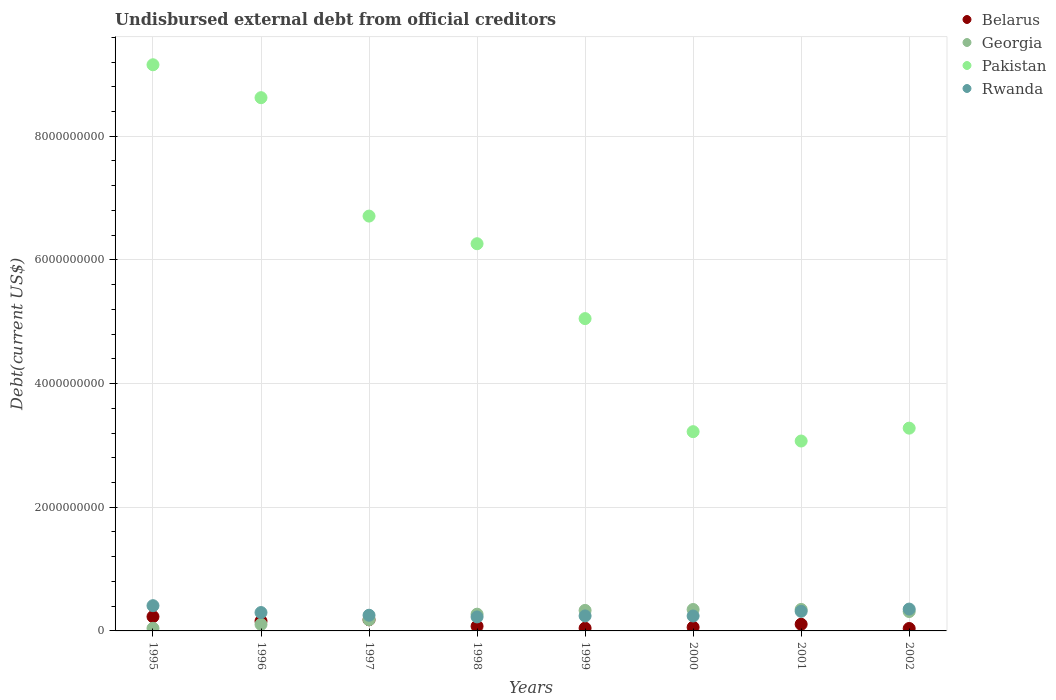What is the total debt in Pakistan in 1999?
Make the answer very short. 5.05e+09. Across all years, what is the maximum total debt in Rwanda?
Offer a terse response. 4.08e+08. Across all years, what is the minimum total debt in Belarus?
Give a very brief answer. 3.94e+07. In which year was the total debt in Rwanda minimum?
Your answer should be compact. 1998. What is the total total debt in Belarus in the graph?
Give a very brief answer. 8.97e+08. What is the difference between the total debt in Rwanda in 1998 and that in 1999?
Your answer should be very brief. -1.64e+07. What is the difference between the total debt in Belarus in 1995 and the total debt in Georgia in 1996?
Your answer should be compact. 1.26e+08. What is the average total debt in Rwanda per year?
Your response must be concise. 2.92e+08. In the year 2002, what is the difference between the total debt in Pakistan and total debt in Belarus?
Ensure brevity in your answer.  3.24e+09. What is the ratio of the total debt in Belarus in 1995 to that in 1996?
Offer a terse response. 1.45. Is the total debt in Pakistan in 1996 less than that in 2002?
Keep it short and to the point. No. Is the difference between the total debt in Pakistan in 2000 and 2002 greater than the difference between the total debt in Belarus in 2000 and 2002?
Provide a short and direct response. No. What is the difference between the highest and the second highest total debt in Pakistan?
Your answer should be very brief. 5.32e+08. What is the difference between the highest and the lowest total debt in Rwanda?
Your answer should be very brief. 1.82e+08. In how many years, is the total debt in Georgia greater than the average total debt in Georgia taken over all years?
Provide a short and direct response. 5. Is the sum of the total debt in Belarus in 1999 and 2000 greater than the maximum total debt in Rwanda across all years?
Ensure brevity in your answer.  No. Does the total debt in Rwanda monotonically increase over the years?
Ensure brevity in your answer.  No. Is the total debt in Georgia strictly less than the total debt in Belarus over the years?
Your response must be concise. No. How many dotlines are there?
Provide a short and direct response. 4. How many years are there in the graph?
Your answer should be very brief. 8. What is the difference between two consecutive major ticks on the Y-axis?
Offer a very short reply. 2.00e+09. Does the graph contain any zero values?
Give a very brief answer. No. How many legend labels are there?
Provide a short and direct response. 4. How are the legend labels stacked?
Offer a very short reply. Vertical. What is the title of the graph?
Provide a short and direct response. Undisbursed external debt from official creditors. Does "Bosnia and Herzegovina" appear as one of the legend labels in the graph?
Make the answer very short. No. What is the label or title of the Y-axis?
Give a very brief answer. Debt(current US$). What is the Debt(current US$) in Belarus in 1995?
Offer a very short reply. 2.31e+08. What is the Debt(current US$) of Georgia in 1995?
Your response must be concise. 4.22e+07. What is the Debt(current US$) in Pakistan in 1995?
Provide a succinct answer. 9.16e+09. What is the Debt(current US$) of Rwanda in 1995?
Keep it short and to the point. 4.08e+08. What is the Debt(current US$) of Belarus in 1996?
Ensure brevity in your answer.  1.59e+08. What is the Debt(current US$) of Georgia in 1996?
Offer a terse response. 1.05e+08. What is the Debt(current US$) in Pakistan in 1996?
Give a very brief answer. 8.62e+09. What is the Debt(current US$) in Rwanda in 1996?
Offer a terse response. 2.97e+08. What is the Debt(current US$) in Belarus in 1997?
Offer a terse response. 1.80e+08. What is the Debt(current US$) of Georgia in 1997?
Your answer should be very brief. 1.81e+08. What is the Debt(current US$) of Pakistan in 1997?
Your answer should be very brief. 6.71e+09. What is the Debt(current US$) of Rwanda in 1997?
Make the answer very short. 2.54e+08. What is the Debt(current US$) in Belarus in 1998?
Make the answer very short. 7.55e+07. What is the Debt(current US$) of Georgia in 1998?
Provide a succinct answer. 2.71e+08. What is the Debt(current US$) of Pakistan in 1998?
Provide a succinct answer. 6.26e+09. What is the Debt(current US$) in Rwanda in 1998?
Offer a terse response. 2.26e+08. What is the Debt(current US$) of Belarus in 1999?
Keep it short and to the point. 4.48e+07. What is the Debt(current US$) of Georgia in 1999?
Give a very brief answer. 3.32e+08. What is the Debt(current US$) in Pakistan in 1999?
Your response must be concise. 5.05e+09. What is the Debt(current US$) of Rwanda in 1999?
Your answer should be compact. 2.43e+08. What is the Debt(current US$) in Belarus in 2000?
Provide a short and direct response. 5.90e+07. What is the Debt(current US$) in Georgia in 2000?
Provide a short and direct response. 3.46e+08. What is the Debt(current US$) of Pakistan in 2000?
Give a very brief answer. 3.22e+09. What is the Debt(current US$) in Rwanda in 2000?
Ensure brevity in your answer.  2.42e+08. What is the Debt(current US$) in Belarus in 2001?
Offer a very short reply. 1.08e+08. What is the Debt(current US$) of Georgia in 2001?
Provide a succinct answer. 3.47e+08. What is the Debt(current US$) of Pakistan in 2001?
Offer a terse response. 3.07e+09. What is the Debt(current US$) of Rwanda in 2001?
Your answer should be compact. 3.17e+08. What is the Debt(current US$) in Belarus in 2002?
Your answer should be very brief. 3.94e+07. What is the Debt(current US$) of Georgia in 2002?
Provide a short and direct response. 3.14e+08. What is the Debt(current US$) in Pakistan in 2002?
Your answer should be very brief. 3.28e+09. What is the Debt(current US$) in Rwanda in 2002?
Offer a very short reply. 3.53e+08. Across all years, what is the maximum Debt(current US$) of Belarus?
Your answer should be compact. 2.31e+08. Across all years, what is the maximum Debt(current US$) in Georgia?
Keep it short and to the point. 3.47e+08. Across all years, what is the maximum Debt(current US$) of Pakistan?
Keep it short and to the point. 9.16e+09. Across all years, what is the maximum Debt(current US$) of Rwanda?
Keep it short and to the point. 4.08e+08. Across all years, what is the minimum Debt(current US$) of Belarus?
Keep it short and to the point. 3.94e+07. Across all years, what is the minimum Debt(current US$) of Georgia?
Ensure brevity in your answer.  4.22e+07. Across all years, what is the minimum Debt(current US$) of Pakistan?
Your response must be concise. 3.07e+09. Across all years, what is the minimum Debt(current US$) in Rwanda?
Your response must be concise. 2.26e+08. What is the total Debt(current US$) in Belarus in the graph?
Provide a short and direct response. 8.97e+08. What is the total Debt(current US$) of Georgia in the graph?
Provide a short and direct response. 1.94e+09. What is the total Debt(current US$) of Pakistan in the graph?
Offer a very short reply. 4.54e+1. What is the total Debt(current US$) of Rwanda in the graph?
Provide a short and direct response. 2.34e+09. What is the difference between the Debt(current US$) of Belarus in 1995 and that in 1996?
Make the answer very short. 7.12e+07. What is the difference between the Debt(current US$) in Georgia in 1995 and that in 1996?
Your answer should be compact. -6.29e+07. What is the difference between the Debt(current US$) in Pakistan in 1995 and that in 1996?
Ensure brevity in your answer.  5.32e+08. What is the difference between the Debt(current US$) in Rwanda in 1995 and that in 1996?
Provide a short and direct response. 1.11e+08. What is the difference between the Debt(current US$) in Belarus in 1995 and that in 1997?
Offer a terse response. 5.06e+07. What is the difference between the Debt(current US$) of Georgia in 1995 and that in 1997?
Your answer should be compact. -1.39e+08. What is the difference between the Debt(current US$) of Pakistan in 1995 and that in 1997?
Provide a short and direct response. 2.45e+09. What is the difference between the Debt(current US$) in Rwanda in 1995 and that in 1997?
Ensure brevity in your answer.  1.55e+08. What is the difference between the Debt(current US$) of Belarus in 1995 and that in 1998?
Your answer should be very brief. 1.55e+08. What is the difference between the Debt(current US$) of Georgia in 1995 and that in 1998?
Keep it short and to the point. -2.29e+08. What is the difference between the Debt(current US$) in Pakistan in 1995 and that in 1998?
Offer a very short reply. 2.89e+09. What is the difference between the Debt(current US$) in Rwanda in 1995 and that in 1998?
Keep it short and to the point. 1.82e+08. What is the difference between the Debt(current US$) of Belarus in 1995 and that in 1999?
Your response must be concise. 1.86e+08. What is the difference between the Debt(current US$) in Georgia in 1995 and that in 1999?
Ensure brevity in your answer.  -2.90e+08. What is the difference between the Debt(current US$) of Pakistan in 1995 and that in 1999?
Keep it short and to the point. 4.11e+09. What is the difference between the Debt(current US$) in Rwanda in 1995 and that in 1999?
Make the answer very short. 1.65e+08. What is the difference between the Debt(current US$) in Belarus in 1995 and that in 2000?
Your answer should be compact. 1.72e+08. What is the difference between the Debt(current US$) in Georgia in 1995 and that in 2000?
Your answer should be very brief. -3.04e+08. What is the difference between the Debt(current US$) in Pakistan in 1995 and that in 2000?
Ensure brevity in your answer.  5.93e+09. What is the difference between the Debt(current US$) of Rwanda in 1995 and that in 2000?
Offer a very short reply. 1.67e+08. What is the difference between the Debt(current US$) in Belarus in 1995 and that in 2001?
Your answer should be very brief. 1.23e+08. What is the difference between the Debt(current US$) of Georgia in 1995 and that in 2001?
Give a very brief answer. -3.05e+08. What is the difference between the Debt(current US$) of Pakistan in 1995 and that in 2001?
Provide a succinct answer. 6.08e+09. What is the difference between the Debt(current US$) in Rwanda in 1995 and that in 2001?
Give a very brief answer. 9.11e+07. What is the difference between the Debt(current US$) in Belarus in 1995 and that in 2002?
Give a very brief answer. 1.91e+08. What is the difference between the Debt(current US$) in Georgia in 1995 and that in 2002?
Provide a short and direct response. -2.71e+08. What is the difference between the Debt(current US$) of Pakistan in 1995 and that in 2002?
Provide a short and direct response. 5.88e+09. What is the difference between the Debt(current US$) of Rwanda in 1995 and that in 2002?
Keep it short and to the point. 5.49e+07. What is the difference between the Debt(current US$) in Belarus in 1996 and that in 1997?
Your answer should be compact. -2.06e+07. What is the difference between the Debt(current US$) of Georgia in 1996 and that in 1997?
Your answer should be very brief. -7.58e+07. What is the difference between the Debt(current US$) of Pakistan in 1996 and that in 1997?
Your answer should be compact. 1.91e+09. What is the difference between the Debt(current US$) of Rwanda in 1996 and that in 1997?
Your answer should be very brief. 4.35e+07. What is the difference between the Debt(current US$) of Belarus in 1996 and that in 1998?
Your response must be concise. 8.40e+07. What is the difference between the Debt(current US$) of Georgia in 1996 and that in 1998?
Make the answer very short. -1.66e+08. What is the difference between the Debt(current US$) of Pakistan in 1996 and that in 1998?
Provide a succinct answer. 2.36e+09. What is the difference between the Debt(current US$) of Rwanda in 1996 and that in 1998?
Provide a succinct answer. 7.08e+07. What is the difference between the Debt(current US$) in Belarus in 1996 and that in 1999?
Offer a very short reply. 1.15e+08. What is the difference between the Debt(current US$) of Georgia in 1996 and that in 1999?
Your answer should be very brief. -2.27e+08. What is the difference between the Debt(current US$) in Pakistan in 1996 and that in 1999?
Give a very brief answer. 3.57e+09. What is the difference between the Debt(current US$) of Rwanda in 1996 and that in 1999?
Provide a short and direct response. 5.44e+07. What is the difference between the Debt(current US$) of Belarus in 1996 and that in 2000?
Your answer should be very brief. 1.00e+08. What is the difference between the Debt(current US$) in Georgia in 1996 and that in 2000?
Provide a short and direct response. -2.41e+08. What is the difference between the Debt(current US$) in Pakistan in 1996 and that in 2000?
Keep it short and to the point. 5.40e+09. What is the difference between the Debt(current US$) in Rwanda in 1996 and that in 2000?
Your answer should be very brief. 5.55e+07. What is the difference between the Debt(current US$) of Belarus in 1996 and that in 2001?
Keep it short and to the point. 5.16e+07. What is the difference between the Debt(current US$) of Georgia in 1996 and that in 2001?
Provide a short and direct response. -2.42e+08. What is the difference between the Debt(current US$) of Pakistan in 1996 and that in 2001?
Make the answer very short. 5.55e+09. What is the difference between the Debt(current US$) of Rwanda in 1996 and that in 2001?
Offer a terse response. -1.99e+07. What is the difference between the Debt(current US$) in Belarus in 1996 and that in 2002?
Provide a short and direct response. 1.20e+08. What is the difference between the Debt(current US$) in Georgia in 1996 and that in 2002?
Ensure brevity in your answer.  -2.09e+08. What is the difference between the Debt(current US$) in Pakistan in 1996 and that in 2002?
Offer a terse response. 5.34e+09. What is the difference between the Debt(current US$) in Rwanda in 1996 and that in 2002?
Ensure brevity in your answer.  -5.61e+07. What is the difference between the Debt(current US$) in Belarus in 1997 and that in 1998?
Your response must be concise. 1.05e+08. What is the difference between the Debt(current US$) in Georgia in 1997 and that in 1998?
Offer a terse response. -8.99e+07. What is the difference between the Debt(current US$) of Pakistan in 1997 and that in 1998?
Ensure brevity in your answer.  4.47e+08. What is the difference between the Debt(current US$) of Rwanda in 1997 and that in 1998?
Your response must be concise. 2.73e+07. What is the difference between the Debt(current US$) of Belarus in 1997 and that in 1999?
Your answer should be compact. 1.35e+08. What is the difference between the Debt(current US$) of Georgia in 1997 and that in 1999?
Make the answer very short. -1.51e+08. What is the difference between the Debt(current US$) of Pakistan in 1997 and that in 1999?
Your answer should be compact. 1.66e+09. What is the difference between the Debt(current US$) in Rwanda in 1997 and that in 1999?
Provide a short and direct response. 1.09e+07. What is the difference between the Debt(current US$) in Belarus in 1997 and that in 2000?
Offer a terse response. 1.21e+08. What is the difference between the Debt(current US$) of Georgia in 1997 and that in 2000?
Ensure brevity in your answer.  -1.65e+08. What is the difference between the Debt(current US$) in Pakistan in 1997 and that in 2000?
Your answer should be very brief. 3.49e+09. What is the difference between the Debt(current US$) of Rwanda in 1997 and that in 2000?
Offer a very short reply. 1.20e+07. What is the difference between the Debt(current US$) of Belarus in 1997 and that in 2001?
Give a very brief answer. 7.22e+07. What is the difference between the Debt(current US$) in Georgia in 1997 and that in 2001?
Offer a very short reply. -1.66e+08. What is the difference between the Debt(current US$) of Pakistan in 1997 and that in 2001?
Offer a very short reply. 3.64e+09. What is the difference between the Debt(current US$) of Rwanda in 1997 and that in 2001?
Offer a very short reply. -6.35e+07. What is the difference between the Debt(current US$) of Belarus in 1997 and that in 2002?
Keep it short and to the point. 1.41e+08. What is the difference between the Debt(current US$) of Georgia in 1997 and that in 2002?
Offer a terse response. -1.33e+08. What is the difference between the Debt(current US$) in Pakistan in 1997 and that in 2002?
Your response must be concise. 3.43e+09. What is the difference between the Debt(current US$) in Rwanda in 1997 and that in 2002?
Your answer should be compact. -9.96e+07. What is the difference between the Debt(current US$) of Belarus in 1998 and that in 1999?
Offer a very short reply. 3.07e+07. What is the difference between the Debt(current US$) of Georgia in 1998 and that in 1999?
Keep it short and to the point. -6.10e+07. What is the difference between the Debt(current US$) of Pakistan in 1998 and that in 1999?
Your response must be concise. 1.21e+09. What is the difference between the Debt(current US$) in Rwanda in 1998 and that in 1999?
Your answer should be very brief. -1.64e+07. What is the difference between the Debt(current US$) in Belarus in 1998 and that in 2000?
Offer a terse response. 1.64e+07. What is the difference between the Debt(current US$) of Georgia in 1998 and that in 2000?
Your answer should be very brief. -7.55e+07. What is the difference between the Debt(current US$) in Pakistan in 1998 and that in 2000?
Offer a very short reply. 3.04e+09. What is the difference between the Debt(current US$) of Rwanda in 1998 and that in 2000?
Your answer should be very brief. -1.52e+07. What is the difference between the Debt(current US$) in Belarus in 1998 and that in 2001?
Keep it short and to the point. -3.24e+07. What is the difference between the Debt(current US$) of Georgia in 1998 and that in 2001?
Your answer should be very brief. -7.65e+07. What is the difference between the Debt(current US$) in Pakistan in 1998 and that in 2001?
Your answer should be very brief. 3.19e+09. What is the difference between the Debt(current US$) of Rwanda in 1998 and that in 2001?
Your response must be concise. -9.07e+07. What is the difference between the Debt(current US$) in Belarus in 1998 and that in 2002?
Offer a very short reply. 3.61e+07. What is the difference between the Debt(current US$) of Georgia in 1998 and that in 2002?
Offer a terse response. -4.28e+07. What is the difference between the Debt(current US$) in Pakistan in 1998 and that in 2002?
Keep it short and to the point. 2.98e+09. What is the difference between the Debt(current US$) in Rwanda in 1998 and that in 2002?
Provide a succinct answer. -1.27e+08. What is the difference between the Debt(current US$) of Belarus in 1999 and that in 2000?
Your response must be concise. -1.43e+07. What is the difference between the Debt(current US$) in Georgia in 1999 and that in 2000?
Provide a succinct answer. -1.45e+07. What is the difference between the Debt(current US$) of Pakistan in 1999 and that in 2000?
Offer a very short reply. 1.83e+09. What is the difference between the Debt(current US$) in Rwanda in 1999 and that in 2000?
Provide a short and direct response. 1.11e+06. What is the difference between the Debt(current US$) of Belarus in 1999 and that in 2001?
Your answer should be compact. -6.31e+07. What is the difference between the Debt(current US$) of Georgia in 1999 and that in 2001?
Offer a terse response. -1.55e+07. What is the difference between the Debt(current US$) in Pakistan in 1999 and that in 2001?
Ensure brevity in your answer.  1.98e+09. What is the difference between the Debt(current US$) of Rwanda in 1999 and that in 2001?
Your answer should be compact. -7.43e+07. What is the difference between the Debt(current US$) of Belarus in 1999 and that in 2002?
Your answer should be very brief. 5.39e+06. What is the difference between the Debt(current US$) in Georgia in 1999 and that in 2002?
Give a very brief answer. 1.82e+07. What is the difference between the Debt(current US$) in Pakistan in 1999 and that in 2002?
Make the answer very short. 1.77e+09. What is the difference between the Debt(current US$) of Rwanda in 1999 and that in 2002?
Your answer should be compact. -1.11e+08. What is the difference between the Debt(current US$) in Belarus in 2000 and that in 2001?
Your answer should be very brief. -4.88e+07. What is the difference between the Debt(current US$) of Georgia in 2000 and that in 2001?
Ensure brevity in your answer.  -1.02e+06. What is the difference between the Debt(current US$) in Pakistan in 2000 and that in 2001?
Provide a succinct answer. 1.51e+08. What is the difference between the Debt(current US$) in Rwanda in 2000 and that in 2001?
Your response must be concise. -7.55e+07. What is the difference between the Debt(current US$) of Belarus in 2000 and that in 2002?
Provide a short and direct response. 1.96e+07. What is the difference between the Debt(current US$) in Georgia in 2000 and that in 2002?
Provide a succinct answer. 3.27e+07. What is the difference between the Debt(current US$) of Pakistan in 2000 and that in 2002?
Ensure brevity in your answer.  -5.69e+07. What is the difference between the Debt(current US$) of Rwanda in 2000 and that in 2002?
Offer a very short reply. -1.12e+08. What is the difference between the Debt(current US$) of Belarus in 2001 and that in 2002?
Provide a short and direct response. 6.85e+07. What is the difference between the Debt(current US$) of Georgia in 2001 and that in 2002?
Your answer should be compact. 3.37e+07. What is the difference between the Debt(current US$) of Pakistan in 2001 and that in 2002?
Provide a succinct answer. -2.08e+08. What is the difference between the Debt(current US$) in Rwanda in 2001 and that in 2002?
Provide a short and direct response. -3.62e+07. What is the difference between the Debt(current US$) in Belarus in 1995 and the Debt(current US$) in Georgia in 1996?
Your answer should be very brief. 1.26e+08. What is the difference between the Debt(current US$) in Belarus in 1995 and the Debt(current US$) in Pakistan in 1996?
Offer a terse response. -8.39e+09. What is the difference between the Debt(current US$) of Belarus in 1995 and the Debt(current US$) of Rwanda in 1996?
Give a very brief answer. -6.65e+07. What is the difference between the Debt(current US$) of Georgia in 1995 and the Debt(current US$) of Pakistan in 1996?
Offer a very short reply. -8.58e+09. What is the difference between the Debt(current US$) of Georgia in 1995 and the Debt(current US$) of Rwanda in 1996?
Your answer should be compact. -2.55e+08. What is the difference between the Debt(current US$) in Pakistan in 1995 and the Debt(current US$) in Rwanda in 1996?
Your answer should be compact. 8.86e+09. What is the difference between the Debt(current US$) in Belarus in 1995 and the Debt(current US$) in Georgia in 1997?
Offer a terse response. 4.98e+07. What is the difference between the Debt(current US$) in Belarus in 1995 and the Debt(current US$) in Pakistan in 1997?
Your answer should be very brief. -6.48e+09. What is the difference between the Debt(current US$) in Belarus in 1995 and the Debt(current US$) in Rwanda in 1997?
Ensure brevity in your answer.  -2.30e+07. What is the difference between the Debt(current US$) in Georgia in 1995 and the Debt(current US$) in Pakistan in 1997?
Your answer should be very brief. -6.67e+09. What is the difference between the Debt(current US$) of Georgia in 1995 and the Debt(current US$) of Rwanda in 1997?
Provide a short and direct response. -2.11e+08. What is the difference between the Debt(current US$) of Pakistan in 1995 and the Debt(current US$) of Rwanda in 1997?
Ensure brevity in your answer.  8.90e+09. What is the difference between the Debt(current US$) of Belarus in 1995 and the Debt(current US$) of Georgia in 1998?
Provide a succinct answer. -4.01e+07. What is the difference between the Debt(current US$) of Belarus in 1995 and the Debt(current US$) of Pakistan in 1998?
Give a very brief answer. -6.03e+09. What is the difference between the Debt(current US$) of Belarus in 1995 and the Debt(current US$) of Rwanda in 1998?
Offer a terse response. 4.30e+06. What is the difference between the Debt(current US$) of Georgia in 1995 and the Debt(current US$) of Pakistan in 1998?
Provide a short and direct response. -6.22e+09. What is the difference between the Debt(current US$) of Georgia in 1995 and the Debt(current US$) of Rwanda in 1998?
Provide a short and direct response. -1.84e+08. What is the difference between the Debt(current US$) of Pakistan in 1995 and the Debt(current US$) of Rwanda in 1998?
Your response must be concise. 8.93e+09. What is the difference between the Debt(current US$) of Belarus in 1995 and the Debt(current US$) of Georgia in 1999?
Offer a very short reply. -1.01e+08. What is the difference between the Debt(current US$) of Belarus in 1995 and the Debt(current US$) of Pakistan in 1999?
Your response must be concise. -4.82e+09. What is the difference between the Debt(current US$) in Belarus in 1995 and the Debt(current US$) in Rwanda in 1999?
Provide a short and direct response. -1.21e+07. What is the difference between the Debt(current US$) in Georgia in 1995 and the Debt(current US$) in Pakistan in 1999?
Provide a short and direct response. -5.01e+09. What is the difference between the Debt(current US$) of Georgia in 1995 and the Debt(current US$) of Rwanda in 1999?
Ensure brevity in your answer.  -2.01e+08. What is the difference between the Debt(current US$) in Pakistan in 1995 and the Debt(current US$) in Rwanda in 1999?
Offer a terse response. 8.91e+09. What is the difference between the Debt(current US$) in Belarus in 1995 and the Debt(current US$) in Georgia in 2000?
Your answer should be very brief. -1.16e+08. What is the difference between the Debt(current US$) of Belarus in 1995 and the Debt(current US$) of Pakistan in 2000?
Give a very brief answer. -2.99e+09. What is the difference between the Debt(current US$) in Belarus in 1995 and the Debt(current US$) in Rwanda in 2000?
Offer a very short reply. -1.10e+07. What is the difference between the Debt(current US$) of Georgia in 1995 and the Debt(current US$) of Pakistan in 2000?
Give a very brief answer. -3.18e+09. What is the difference between the Debt(current US$) of Georgia in 1995 and the Debt(current US$) of Rwanda in 2000?
Your response must be concise. -1.99e+08. What is the difference between the Debt(current US$) in Pakistan in 1995 and the Debt(current US$) in Rwanda in 2000?
Keep it short and to the point. 8.91e+09. What is the difference between the Debt(current US$) of Belarus in 1995 and the Debt(current US$) of Georgia in 2001?
Ensure brevity in your answer.  -1.17e+08. What is the difference between the Debt(current US$) of Belarus in 1995 and the Debt(current US$) of Pakistan in 2001?
Give a very brief answer. -2.84e+09. What is the difference between the Debt(current US$) of Belarus in 1995 and the Debt(current US$) of Rwanda in 2001?
Provide a succinct answer. -8.64e+07. What is the difference between the Debt(current US$) of Georgia in 1995 and the Debt(current US$) of Pakistan in 2001?
Keep it short and to the point. -3.03e+09. What is the difference between the Debt(current US$) in Georgia in 1995 and the Debt(current US$) in Rwanda in 2001?
Provide a succinct answer. -2.75e+08. What is the difference between the Debt(current US$) of Pakistan in 1995 and the Debt(current US$) of Rwanda in 2001?
Your answer should be very brief. 8.84e+09. What is the difference between the Debt(current US$) of Belarus in 1995 and the Debt(current US$) of Georgia in 2002?
Give a very brief answer. -8.29e+07. What is the difference between the Debt(current US$) in Belarus in 1995 and the Debt(current US$) in Pakistan in 2002?
Your answer should be compact. -3.05e+09. What is the difference between the Debt(current US$) in Belarus in 1995 and the Debt(current US$) in Rwanda in 2002?
Provide a succinct answer. -1.23e+08. What is the difference between the Debt(current US$) in Georgia in 1995 and the Debt(current US$) in Pakistan in 2002?
Offer a very short reply. -3.24e+09. What is the difference between the Debt(current US$) in Georgia in 1995 and the Debt(current US$) in Rwanda in 2002?
Make the answer very short. -3.11e+08. What is the difference between the Debt(current US$) of Pakistan in 1995 and the Debt(current US$) of Rwanda in 2002?
Offer a terse response. 8.80e+09. What is the difference between the Debt(current US$) of Belarus in 1996 and the Debt(current US$) of Georgia in 1997?
Ensure brevity in your answer.  -2.14e+07. What is the difference between the Debt(current US$) of Belarus in 1996 and the Debt(current US$) of Pakistan in 1997?
Offer a terse response. -6.55e+09. What is the difference between the Debt(current US$) of Belarus in 1996 and the Debt(current US$) of Rwanda in 1997?
Make the answer very short. -9.42e+07. What is the difference between the Debt(current US$) of Georgia in 1996 and the Debt(current US$) of Pakistan in 1997?
Offer a very short reply. -6.60e+09. What is the difference between the Debt(current US$) in Georgia in 1996 and the Debt(current US$) in Rwanda in 1997?
Provide a succinct answer. -1.49e+08. What is the difference between the Debt(current US$) of Pakistan in 1996 and the Debt(current US$) of Rwanda in 1997?
Your response must be concise. 8.37e+09. What is the difference between the Debt(current US$) in Belarus in 1996 and the Debt(current US$) in Georgia in 1998?
Ensure brevity in your answer.  -1.11e+08. What is the difference between the Debt(current US$) of Belarus in 1996 and the Debt(current US$) of Pakistan in 1998?
Your answer should be very brief. -6.10e+09. What is the difference between the Debt(current US$) of Belarus in 1996 and the Debt(current US$) of Rwanda in 1998?
Give a very brief answer. -6.69e+07. What is the difference between the Debt(current US$) of Georgia in 1996 and the Debt(current US$) of Pakistan in 1998?
Make the answer very short. -6.16e+09. What is the difference between the Debt(current US$) of Georgia in 1996 and the Debt(current US$) of Rwanda in 1998?
Your response must be concise. -1.21e+08. What is the difference between the Debt(current US$) in Pakistan in 1996 and the Debt(current US$) in Rwanda in 1998?
Your response must be concise. 8.40e+09. What is the difference between the Debt(current US$) in Belarus in 1996 and the Debt(current US$) in Georgia in 1999?
Your answer should be compact. -1.72e+08. What is the difference between the Debt(current US$) in Belarus in 1996 and the Debt(current US$) in Pakistan in 1999?
Your answer should be compact. -4.89e+09. What is the difference between the Debt(current US$) of Belarus in 1996 and the Debt(current US$) of Rwanda in 1999?
Provide a short and direct response. -8.33e+07. What is the difference between the Debt(current US$) of Georgia in 1996 and the Debt(current US$) of Pakistan in 1999?
Provide a succinct answer. -4.95e+09. What is the difference between the Debt(current US$) in Georgia in 1996 and the Debt(current US$) in Rwanda in 1999?
Make the answer very short. -1.38e+08. What is the difference between the Debt(current US$) of Pakistan in 1996 and the Debt(current US$) of Rwanda in 1999?
Provide a short and direct response. 8.38e+09. What is the difference between the Debt(current US$) in Belarus in 1996 and the Debt(current US$) in Georgia in 2000?
Give a very brief answer. -1.87e+08. What is the difference between the Debt(current US$) of Belarus in 1996 and the Debt(current US$) of Pakistan in 2000?
Your answer should be very brief. -3.06e+09. What is the difference between the Debt(current US$) in Belarus in 1996 and the Debt(current US$) in Rwanda in 2000?
Your answer should be compact. -8.22e+07. What is the difference between the Debt(current US$) of Georgia in 1996 and the Debt(current US$) of Pakistan in 2000?
Your answer should be very brief. -3.12e+09. What is the difference between the Debt(current US$) of Georgia in 1996 and the Debt(current US$) of Rwanda in 2000?
Provide a succinct answer. -1.37e+08. What is the difference between the Debt(current US$) in Pakistan in 1996 and the Debt(current US$) in Rwanda in 2000?
Your response must be concise. 8.38e+09. What is the difference between the Debt(current US$) in Belarus in 1996 and the Debt(current US$) in Georgia in 2001?
Ensure brevity in your answer.  -1.88e+08. What is the difference between the Debt(current US$) of Belarus in 1996 and the Debt(current US$) of Pakistan in 2001?
Your response must be concise. -2.91e+09. What is the difference between the Debt(current US$) of Belarus in 1996 and the Debt(current US$) of Rwanda in 2001?
Offer a very short reply. -1.58e+08. What is the difference between the Debt(current US$) in Georgia in 1996 and the Debt(current US$) in Pakistan in 2001?
Keep it short and to the point. -2.97e+09. What is the difference between the Debt(current US$) of Georgia in 1996 and the Debt(current US$) of Rwanda in 2001?
Provide a succinct answer. -2.12e+08. What is the difference between the Debt(current US$) in Pakistan in 1996 and the Debt(current US$) in Rwanda in 2001?
Keep it short and to the point. 8.31e+09. What is the difference between the Debt(current US$) in Belarus in 1996 and the Debt(current US$) in Georgia in 2002?
Your answer should be very brief. -1.54e+08. What is the difference between the Debt(current US$) in Belarus in 1996 and the Debt(current US$) in Pakistan in 2002?
Your response must be concise. -3.12e+09. What is the difference between the Debt(current US$) of Belarus in 1996 and the Debt(current US$) of Rwanda in 2002?
Provide a short and direct response. -1.94e+08. What is the difference between the Debt(current US$) of Georgia in 1996 and the Debt(current US$) of Pakistan in 2002?
Provide a short and direct response. -3.17e+09. What is the difference between the Debt(current US$) in Georgia in 1996 and the Debt(current US$) in Rwanda in 2002?
Offer a terse response. -2.48e+08. What is the difference between the Debt(current US$) of Pakistan in 1996 and the Debt(current US$) of Rwanda in 2002?
Your answer should be compact. 8.27e+09. What is the difference between the Debt(current US$) of Belarus in 1997 and the Debt(current US$) of Georgia in 1998?
Make the answer very short. -9.07e+07. What is the difference between the Debt(current US$) in Belarus in 1997 and the Debt(current US$) in Pakistan in 1998?
Keep it short and to the point. -6.08e+09. What is the difference between the Debt(current US$) of Belarus in 1997 and the Debt(current US$) of Rwanda in 1998?
Ensure brevity in your answer.  -4.63e+07. What is the difference between the Debt(current US$) of Georgia in 1997 and the Debt(current US$) of Pakistan in 1998?
Offer a terse response. -6.08e+09. What is the difference between the Debt(current US$) in Georgia in 1997 and the Debt(current US$) in Rwanda in 1998?
Give a very brief answer. -4.55e+07. What is the difference between the Debt(current US$) of Pakistan in 1997 and the Debt(current US$) of Rwanda in 1998?
Ensure brevity in your answer.  6.48e+09. What is the difference between the Debt(current US$) of Belarus in 1997 and the Debt(current US$) of Georgia in 1999?
Your response must be concise. -1.52e+08. What is the difference between the Debt(current US$) in Belarus in 1997 and the Debt(current US$) in Pakistan in 1999?
Give a very brief answer. -4.87e+09. What is the difference between the Debt(current US$) in Belarus in 1997 and the Debt(current US$) in Rwanda in 1999?
Offer a terse response. -6.27e+07. What is the difference between the Debt(current US$) of Georgia in 1997 and the Debt(current US$) of Pakistan in 1999?
Make the answer very short. -4.87e+09. What is the difference between the Debt(current US$) of Georgia in 1997 and the Debt(current US$) of Rwanda in 1999?
Keep it short and to the point. -6.19e+07. What is the difference between the Debt(current US$) in Pakistan in 1997 and the Debt(current US$) in Rwanda in 1999?
Your response must be concise. 6.47e+09. What is the difference between the Debt(current US$) of Belarus in 1997 and the Debt(current US$) of Georgia in 2000?
Keep it short and to the point. -1.66e+08. What is the difference between the Debt(current US$) of Belarus in 1997 and the Debt(current US$) of Pakistan in 2000?
Give a very brief answer. -3.04e+09. What is the difference between the Debt(current US$) in Belarus in 1997 and the Debt(current US$) in Rwanda in 2000?
Provide a short and direct response. -6.16e+07. What is the difference between the Debt(current US$) of Georgia in 1997 and the Debt(current US$) of Pakistan in 2000?
Your response must be concise. -3.04e+09. What is the difference between the Debt(current US$) of Georgia in 1997 and the Debt(current US$) of Rwanda in 2000?
Give a very brief answer. -6.08e+07. What is the difference between the Debt(current US$) in Pakistan in 1997 and the Debt(current US$) in Rwanda in 2000?
Give a very brief answer. 6.47e+09. What is the difference between the Debt(current US$) of Belarus in 1997 and the Debt(current US$) of Georgia in 2001?
Your response must be concise. -1.67e+08. What is the difference between the Debt(current US$) in Belarus in 1997 and the Debt(current US$) in Pakistan in 2001?
Provide a succinct answer. -2.89e+09. What is the difference between the Debt(current US$) of Belarus in 1997 and the Debt(current US$) of Rwanda in 2001?
Provide a succinct answer. -1.37e+08. What is the difference between the Debt(current US$) of Georgia in 1997 and the Debt(current US$) of Pakistan in 2001?
Offer a terse response. -2.89e+09. What is the difference between the Debt(current US$) of Georgia in 1997 and the Debt(current US$) of Rwanda in 2001?
Ensure brevity in your answer.  -1.36e+08. What is the difference between the Debt(current US$) in Pakistan in 1997 and the Debt(current US$) in Rwanda in 2001?
Make the answer very short. 6.39e+09. What is the difference between the Debt(current US$) in Belarus in 1997 and the Debt(current US$) in Georgia in 2002?
Give a very brief answer. -1.34e+08. What is the difference between the Debt(current US$) of Belarus in 1997 and the Debt(current US$) of Pakistan in 2002?
Your answer should be compact. -3.10e+09. What is the difference between the Debt(current US$) in Belarus in 1997 and the Debt(current US$) in Rwanda in 2002?
Provide a short and direct response. -1.73e+08. What is the difference between the Debt(current US$) in Georgia in 1997 and the Debt(current US$) in Pakistan in 2002?
Provide a succinct answer. -3.10e+09. What is the difference between the Debt(current US$) of Georgia in 1997 and the Debt(current US$) of Rwanda in 2002?
Offer a terse response. -1.72e+08. What is the difference between the Debt(current US$) of Pakistan in 1997 and the Debt(current US$) of Rwanda in 2002?
Keep it short and to the point. 6.36e+09. What is the difference between the Debt(current US$) of Belarus in 1998 and the Debt(current US$) of Georgia in 1999?
Your answer should be very brief. -2.56e+08. What is the difference between the Debt(current US$) in Belarus in 1998 and the Debt(current US$) in Pakistan in 1999?
Provide a succinct answer. -4.98e+09. What is the difference between the Debt(current US$) of Belarus in 1998 and the Debt(current US$) of Rwanda in 1999?
Offer a terse response. -1.67e+08. What is the difference between the Debt(current US$) of Georgia in 1998 and the Debt(current US$) of Pakistan in 1999?
Keep it short and to the point. -4.78e+09. What is the difference between the Debt(current US$) in Georgia in 1998 and the Debt(current US$) in Rwanda in 1999?
Provide a succinct answer. 2.80e+07. What is the difference between the Debt(current US$) in Pakistan in 1998 and the Debt(current US$) in Rwanda in 1999?
Your answer should be very brief. 6.02e+09. What is the difference between the Debt(current US$) in Belarus in 1998 and the Debt(current US$) in Georgia in 2000?
Provide a succinct answer. -2.71e+08. What is the difference between the Debt(current US$) in Belarus in 1998 and the Debt(current US$) in Pakistan in 2000?
Offer a very short reply. -3.15e+09. What is the difference between the Debt(current US$) of Belarus in 1998 and the Debt(current US$) of Rwanda in 2000?
Provide a succinct answer. -1.66e+08. What is the difference between the Debt(current US$) of Georgia in 1998 and the Debt(current US$) of Pakistan in 2000?
Give a very brief answer. -2.95e+09. What is the difference between the Debt(current US$) in Georgia in 1998 and the Debt(current US$) in Rwanda in 2000?
Your answer should be very brief. 2.92e+07. What is the difference between the Debt(current US$) of Pakistan in 1998 and the Debt(current US$) of Rwanda in 2000?
Provide a succinct answer. 6.02e+09. What is the difference between the Debt(current US$) of Belarus in 1998 and the Debt(current US$) of Georgia in 2001?
Your answer should be very brief. -2.72e+08. What is the difference between the Debt(current US$) in Belarus in 1998 and the Debt(current US$) in Pakistan in 2001?
Offer a terse response. -3.00e+09. What is the difference between the Debt(current US$) of Belarus in 1998 and the Debt(current US$) of Rwanda in 2001?
Ensure brevity in your answer.  -2.42e+08. What is the difference between the Debt(current US$) of Georgia in 1998 and the Debt(current US$) of Pakistan in 2001?
Offer a terse response. -2.80e+09. What is the difference between the Debt(current US$) in Georgia in 1998 and the Debt(current US$) in Rwanda in 2001?
Your answer should be very brief. -4.63e+07. What is the difference between the Debt(current US$) of Pakistan in 1998 and the Debt(current US$) of Rwanda in 2001?
Your answer should be compact. 5.94e+09. What is the difference between the Debt(current US$) in Belarus in 1998 and the Debt(current US$) in Georgia in 2002?
Offer a terse response. -2.38e+08. What is the difference between the Debt(current US$) of Belarus in 1998 and the Debt(current US$) of Pakistan in 2002?
Keep it short and to the point. -3.20e+09. What is the difference between the Debt(current US$) in Belarus in 1998 and the Debt(current US$) in Rwanda in 2002?
Give a very brief answer. -2.78e+08. What is the difference between the Debt(current US$) of Georgia in 1998 and the Debt(current US$) of Pakistan in 2002?
Your response must be concise. -3.01e+09. What is the difference between the Debt(current US$) in Georgia in 1998 and the Debt(current US$) in Rwanda in 2002?
Offer a very short reply. -8.25e+07. What is the difference between the Debt(current US$) in Pakistan in 1998 and the Debt(current US$) in Rwanda in 2002?
Ensure brevity in your answer.  5.91e+09. What is the difference between the Debt(current US$) in Belarus in 1999 and the Debt(current US$) in Georgia in 2000?
Your answer should be very brief. -3.02e+08. What is the difference between the Debt(current US$) of Belarus in 1999 and the Debt(current US$) of Pakistan in 2000?
Provide a succinct answer. -3.18e+09. What is the difference between the Debt(current US$) in Belarus in 1999 and the Debt(current US$) in Rwanda in 2000?
Your answer should be very brief. -1.97e+08. What is the difference between the Debt(current US$) in Georgia in 1999 and the Debt(current US$) in Pakistan in 2000?
Make the answer very short. -2.89e+09. What is the difference between the Debt(current US$) of Georgia in 1999 and the Debt(current US$) of Rwanda in 2000?
Keep it short and to the point. 9.02e+07. What is the difference between the Debt(current US$) in Pakistan in 1999 and the Debt(current US$) in Rwanda in 2000?
Your answer should be very brief. 4.81e+09. What is the difference between the Debt(current US$) of Belarus in 1999 and the Debt(current US$) of Georgia in 2001?
Keep it short and to the point. -3.03e+08. What is the difference between the Debt(current US$) of Belarus in 1999 and the Debt(current US$) of Pakistan in 2001?
Offer a very short reply. -3.03e+09. What is the difference between the Debt(current US$) in Belarus in 1999 and the Debt(current US$) in Rwanda in 2001?
Provide a short and direct response. -2.72e+08. What is the difference between the Debt(current US$) in Georgia in 1999 and the Debt(current US$) in Pakistan in 2001?
Offer a very short reply. -2.74e+09. What is the difference between the Debt(current US$) in Georgia in 1999 and the Debt(current US$) in Rwanda in 2001?
Keep it short and to the point. 1.47e+07. What is the difference between the Debt(current US$) in Pakistan in 1999 and the Debt(current US$) in Rwanda in 2001?
Your answer should be compact. 4.73e+09. What is the difference between the Debt(current US$) in Belarus in 1999 and the Debt(current US$) in Georgia in 2002?
Your answer should be very brief. -2.69e+08. What is the difference between the Debt(current US$) of Belarus in 1999 and the Debt(current US$) of Pakistan in 2002?
Provide a short and direct response. -3.23e+09. What is the difference between the Debt(current US$) in Belarus in 1999 and the Debt(current US$) in Rwanda in 2002?
Provide a short and direct response. -3.08e+08. What is the difference between the Debt(current US$) in Georgia in 1999 and the Debt(current US$) in Pakistan in 2002?
Ensure brevity in your answer.  -2.95e+09. What is the difference between the Debt(current US$) of Georgia in 1999 and the Debt(current US$) of Rwanda in 2002?
Provide a short and direct response. -2.15e+07. What is the difference between the Debt(current US$) in Pakistan in 1999 and the Debt(current US$) in Rwanda in 2002?
Give a very brief answer. 4.70e+09. What is the difference between the Debt(current US$) of Belarus in 2000 and the Debt(current US$) of Georgia in 2001?
Your answer should be compact. -2.88e+08. What is the difference between the Debt(current US$) of Belarus in 2000 and the Debt(current US$) of Pakistan in 2001?
Your answer should be compact. -3.01e+09. What is the difference between the Debt(current US$) of Belarus in 2000 and the Debt(current US$) of Rwanda in 2001?
Ensure brevity in your answer.  -2.58e+08. What is the difference between the Debt(current US$) in Georgia in 2000 and the Debt(current US$) in Pakistan in 2001?
Provide a succinct answer. -2.72e+09. What is the difference between the Debt(current US$) in Georgia in 2000 and the Debt(current US$) in Rwanda in 2001?
Make the answer very short. 2.92e+07. What is the difference between the Debt(current US$) in Pakistan in 2000 and the Debt(current US$) in Rwanda in 2001?
Offer a very short reply. 2.91e+09. What is the difference between the Debt(current US$) of Belarus in 2000 and the Debt(current US$) of Georgia in 2002?
Give a very brief answer. -2.55e+08. What is the difference between the Debt(current US$) in Belarus in 2000 and the Debt(current US$) in Pakistan in 2002?
Keep it short and to the point. -3.22e+09. What is the difference between the Debt(current US$) of Belarus in 2000 and the Debt(current US$) of Rwanda in 2002?
Provide a succinct answer. -2.94e+08. What is the difference between the Debt(current US$) in Georgia in 2000 and the Debt(current US$) in Pakistan in 2002?
Provide a short and direct response. -2.93e+09. What is the difference between the Debt(current US$) in Georgia in 2000 and the Debt(current US$) in Rwanda in 2002?
Your response must be concise. -6.97e+06. What is the difference between the Debt(current US$) of Pakistan in 2000 and the Debt(current US$) of Rwanda in 2002?
Keep it short and to the point. 2.87e+09. What is the difference between the Debt(current US$) in Belarus in 2001 and the Debt(current US$) in Georgia in 2002?
Offer a very short reply. -2.06e+08. What is the difference between the Debt(current US$) of Belarus in 2001 and the Debt(current US$) of Pakistan in 2002?
Make the answer very short. -3.17e+09. What is the difference between the Debt(current US$) in Belarus in 2001 and the Debt(current US$) in Rwanda in 2002?
Provide a succinct answer. -2.45e+08. What is the difference between the Debt(current US$) in Georgia in 2001 and the Debt(current US$) in Pakistan in 2002?
Offer a very short reply. -2.93e+09. What is the difference between the Debt(current US$) of Georgia in 2001 and the Debt(current US$) of Rwanda in 2002?
Ensure brevity in your answer.  -5.95e+06. What is the difference between the Debt(current US$) in Pakistan in 2001 and the Debt(current US$) in Rwanda in 2002?
Ensure brevity in your answer.  2.72e+09. What is the average Debt(current US$) in Belarus per year?
Provide a short and direct response. 1.12e+08. What is the average Debt(current US$) in Georgia per year?
Make the answer very short. 2.42e+08. What is the average Debt(current US$) of Pakistan per year?
Make the answer very short. 5.67e+09. What is the average Debt(current US$) of Rwanda per year?
Provide a succinct answer. 2.92e+08. In the year 1995, what is the difference between the Debt(current US$) in Belarus and Debt(current US$) in Georgia?
Make the answer very short. 1.88e+08. In the year 1995, what is the difference between the Debt(current US$) in Belarus and Debt(current US$) in Pakistan?
Provide a succinct answer. -8.93e+09. In the year 1995, what is the difference between the Debt(current US$) in Belarus and Debt(current US$) in Rwanda?
Provide a short and direct response. -1.77e+08. In the year 1995, what is the difference between the Debt(current US$) in Georgia and Debt(current US$) in Pakistan?
Your response must be concise. -9.11e+09. In the year 1995, what is the difference between the Debt(current US$) in Georgia and Debt(current US$) in Rwanda?
Offer a terse response. -3.66e+08. In the year 1995, what is the difference between the Debt(current US$) of Pakistan and Debt(current US$) of Rwanda?
Your response must be concise. 8.75e+09. In the year 1996, what is the difference between the Debt(current US$) of Belarus and Debt(current US$) of Georgia?
Your response must be concise. 5.44e+07. In the year 1996, what is the difference between the Debt(current US$) in Belarus and Debt(current US$) in Pakistan?
Offer a terse response. -8.46e+09. In the year 1996, what is the difference between the Debt(current US$) in Belarus and Debt(current US$) in Rwanda?
Offer a terse response. -1.38e+08. In the year 1996, what is the difference between the Debt(current US$) in Georgia and Debt(current US$) in Pakistan?
Offer a terse response. -8.52e+09. In the year 1996, what is the difference between the Debt(current US$) of Georgia and Debt(current US$) of Rwanda?
Your response must be concise. -1.92e+08. In the year 1996, what is the difference between the Debt(current US$) of Pakistan and Debt(current US$) of Rwanda?
Keep it short and to the point. 8.33e+09. In the year 1997, what is the difference between the Debt(current US$) in Belarus and Debt(current US$) in Georgia?
Ensure brevity in your answer.  -7.80e+05. In the year 1997, what is the difference between the Debt(current US$) of Belarus and Debt(current US$) of Pakistan?
Give a very brief answer. -6.53e+09. In the year 1997, what is the difference between the Debt(current US$) of Belarus and Debt(current US$) of Rwanda?
Ensure brevity in your answer.  -7.36e+07. In the year 1997, what is the difference between the Debt(current US$) in Georgia and Debt(current US$) in Pakistan?
Your answer should be compact. -6.53e+09. In the year 1997, what is the difference between the Debt(current US$) in Georgia and Debt(current US$) in Rwanda?
Offer a terse response. -7.28e+07. In the year 1997, what is the difference between the Debt(current US$) of Pakistan and Debt(current US$) of Rwanda?
Your answer should be compact. 6.45e+09. In the year 1998, what is the difference between the Debt(current US$) of Belarus and Debt(current US$) of Georgia?
Keep it short and to the point. -1.95e+08. In the year 1998, what is the difference between the Debt(current US$) of Belarus and Debt(current US$) of Pakistan?
Provide a succinct answer. -6.19e+09. In the year 1998, what is the difference between the Debt(current US$) of Belarus and Debt(current US$) of Rwanda?
Provide a short and direct response. -1.51e+08. In the year 1998, what is the difference between the Debt(current US$) in Georgia and Debt(current US$) in Pakistan?
Offer a terse response. -5.99e+09. In the year 1998, what is the difference between the Debt(current US$) of Georgia and Debt(current US$) of Rwanda?
Your answer should be very brief. 4.44e+07. In the year 1998, what is the difference between the Debt(current US$) of Pakistan and Debt(current US$) of Rwanda?
Provide a succinct answer. 6.04e+09. In the year 1999, what is the difference between the Debt(current US$) of Belarus and Debt(current US$) of Georgia?
Provide a short and direct response. -2.87e+08. In the year 1999, what is the difference between the Debt(current US$) in Belarus and Debt(current US$) in Pakistan?
Ensure brevity in your answer.  -5.01e+09. In the year 1999, what is the difference between the Debt(current US$) of Belarus and Debt(current US$) of Rwanda?
Your response must be concise. -1.98e+08. In the year 1999, what is the difference between the Debt(current US$) in Georgia and Debt(current US$) in Pakistan?
Provide a succinct answer. -4.72e+09. In the year 1999, what is the difference between the Debt(current US$) of Georgia and Debt(current US$) of Rwanda?
Your answer should be compact. 8.91e+07. In the year 1999, what is the difference between the Debt(current US$) of Pakistan and Debt(current US$) of Rwanda?
Ensure brevity in your answer.  4.81e+09. In the year 2000, what is the difference between the Debt(current US$) in Belarus and Debt(current US$) in Georgia?
Your response must be concise. -2.87e+08. In the year 2000, what is the difference between the Debt(current US$) of Belarus and Debt(current US$) of Pakistan?
Your answer should be very brief. -3.16e+09. In the year 2000, what is the difference between the Debt(current US$) in Belarus and Debt(current US$) in Rwanda?
Ensure brevity in your answer.  -1.83e+08. In the year 2000, what is the difference between the Debt(current US$) in Georgia and Debt(current US$) in Pakistan?
Keep it short and to the point. -2.88e+09. In the year 2000, what is the difference between the Debt(current US$) in Georgia and Debt(current US$) in Rwanda?
Offer a very short reply. 1.05e+08. In the year 2000, what is the difference between the Debt(current US$) of Pakistan and Debt(current US$) of Rwanda?
Ensure brevity in your answer.  2.98e+09. In the year 2001, what is the difference between the Debt(current US$) of Belarus and Debt(current US$) of Georgia?
Make the answer very short. -2.39e+08. In the year 2001, what is the difference between the Debt(current US$) of Belarus and Debt(current US$) of Pakistan?
Give a very brief answer. -2.96e+09. In the year 2001, what is the difference between the Debt(current US$) of Belarus and Debt(current US$) of Rwanda?
Your answer should be very brief. -2.09e+08. In the year 2001, what is the difference between the Debt(current US$) of Georgia and Debt(current US$) of Pakistan?
Keep it short and to the point. -2.72e+09. In the year 2001, what is the difference between the Debt(current US$) in Georgia and Debt(current US$) in Rwanda?
Provide a succinct answer. 3.02e+07. In the year 2001, what is the difference between the Debt(current US$) in Pakistan and Debt(current US$) in Rwanda?
Offer a terse response. 2.75e+09. In the year 2002, what is the difference between the Debt(current US$) in Belarus and Debt(current US$) in Georgia?
Your answer should be compact. -2.74e+08. In the year 2002, what is the difference between the Debt(current US$) of Belarus and Debt(current US$) of Pakistan?
Make the answer very short. -3.24e+09. In the year 2002, what is the difference between the Debt(current US$) in Belarus and Debt(current US$) in Rwanda?
Make the answer very short. -3.14e+08. In the year 2002, what is the difference between the Debt(current US$) in Georgia and Debt(current US$) in Pakistan?
Your answer should be compact. -2.97e+09. In the year 2002, what is the difference between the Debt(current US$) of Georgia and Debt(current US$) of Rwanda?
Provide a short and direct response. -3.97e+07. In the year 2002, what is the difference between the Debt(current US$) of Pakistan and Debt(current US$) of Rwanda?
Provide a succinct answer. 2.93e+09. What is the ratio of the Debt(current US$) in Belarus in 1995 to that in 1996?
Your answer should be compact. 1.45. What is the ratio of the Debt(current US$) of Georgia in 1995 to that in 1996?
Offer a terse response. 0.4. What is the ratio of the Debt(current US$) of Pakistan in 1995 to that in 1996?
Offer a very short reply. 1.06. What is the ratio of the Debt(current US$) of Rwanda in 1995 to that in 1996?
Your response must be concise. 1.37. What is the ratio of the Debt(current US$) of Belarus in 1995 to that in 1997?
Provide a short and direct response. 1.28. What is the ratio of the Debt(current US$) in Georgia in 1995 to that in 1997?
Offer a terse response. 0.23. What is the ratio of the Debt(current US$) in Pakistan in 1995 to that in 1997?
Offer a terse response. 1.36. What is the ratio of the Debt(current US$) of Rwanda in 1995 to that in 1997?
Your answer should be compact. 1.61. What is the ratio of the Debt(current US$) in Belarus in 1995 to that in 1998?
Provide a short and direct response. 3.06. What is the ratio of the Debt(current US$) in Georgia in 1995 to that in 1998?
Your answer should be very brief. 0.16. What is the ratio of the Debt(current US$) in Pakistan in 1995 to that in 1998?
Make the answer very short. 1.46. What is the ratio of the Debt(current US$) in Rwanda in 1995 to that in 1998?
Ensure brevity in your answer.  1.8. What is the ratio of the Debt(current US$) of Belarus in 1995 to that in 1999?
Provide a short and direct response. 5.15. What is the ratio of the Debt(current US$) of Georgia in 1995 to that in 1999?
Provide a short and direct response. 0.13. What is the ratio of the Debt(current US$) in Pakistan in 1995 to that in 1999?
Provide a succinct answer. 1.81. What is the ratio of the Debt(current US$) of Rwanda in 1995 to that in 1999?
Make the answer very short. 1.68. What is the ratio of the Debt(current US$) in Belarus in 1995 to that in 2000?
Provide a succinct answer. 3.91. What is the ratio of the Debt(current US$) of Georgia in 1995 to that in 2000?
Give a very brief answer. 0.12. What is the ratio of the Debt(current US$) in Pakistan in 1995 to that in 2000?
Ensure brevity in your answer.  2.84. What is the ratio of the Debt(current US$) in Rwanda in 1995 to that in 2000?
Make the answer very short. 1.69. What is the ratio of the Debt(current US$) in Belarus in 1995 to that in 2001?
Your response must be concise. 2.14. What is the ratio of the Debt(current US$) of Georgia in 1995 to that in 2001?
Your response must be concise. 0.12. What is the ratio of the Debt(current US$) in Pakistan in 1995 to that in 2001?
Offer a terse response. 2.98. What is the ratio of the Debt(current US$) of Rwanda in 1995 to that in 2001?
Give a very brief answer. 1.29. What is the ratio of the Debt(current US$) in Belarus in 1995 to that in 2002?
Your answer should be compact. 5.86. What is the ratio of the Debt(current US$) in Georgia in 1995 to that in 2002?
Provide a short and direct response. 0.13. What is the ratio of the Debt(current US$) of Pakistan in 1995 to that in 2002?
Provide a succinct answer. 2.79. What is the ratio of the Debt(current US$) in Rwanda in 1995 to that in 2002?
Your answer should be very brief. 1.16. What is the ratio of the Debt(current US$) in Belarus in 1996 to that in 1997?
Your answer should be compact. 0.89. What is the ratio of the Debt(current US$) of Georgia in 1996 to that in 1997?
Give a very brief answer. 0.58. What is the ratio of the Debt(current US$) of Pakistan in 1996 to that in 1997?
Ensure brevity in your answer.  1.29. What is the ratio of the Debt(current US$) of Rwanda in 1996 to that in 1997?
Provide a succinct answer. 1.17. What is the ratio of the Debt(current US$) in Belarus in 1996 to that in 1998?
Offer a very short reply. 2.11. What is the ratio of the Debt(current US$) in Georgia in 1996 to that in 1998?
Offer a very short reply. 0.39. What is the ratio of the Debt(current US$) in Pakistan in 1996 to that in 1998?
Make the answer very short. 1.38. What is the ratio of the Debt(current US$) of Rwanda in 1996 to that in 1998?
Your answer should be very brief. 1.31. What is the ratio of the Debt(current US$) in Belarus in 1996 to that in 1999?
Provide a short and direct response. 3.56. What is the ratio of the Debt(current US$) in Georgia in 1996 to that in 1999?
Make the answer very short. 0.32. What is the ratio of the Debt(current US$) of Pakistan in 1996 to that in 1999?
Offer a terse response. 1.71. What is the ratio of the Debt(current US$) of Rwanda in 1996 to that in 1999?
Give a very brief answer. 1.22. What is the ratio of the Debt(current US$) of Belarus in 1996 to that in 2000?
Your answer should be compact. 2.7. What is the ratio of the Debt(current US$) of Georgia in 1996 to that in 2000?
Offer a terse response. 0.3. What is the ratio of the Debt(current US$) of Pakistan in 1996 to that in 2000?
Offer a terse response. 2.68. What is the ratio of the Debt(current US$) in Rwanda in 1996 to that in 2000?
Ensure brevity in your answer.  1.23. What is the ratio of the Debt(current US$) of Belarus in 1996 to that in 2001?
Keep it short and to the point. 1.48. What is the ratio of the Debt(current US$) of Georgia in 1996 to that in 2001?
Give a very brief answer. 0.3. What is the ratio of the Debt(current US$) of Pakistan in 1996 to that in 2001?
Your response must be concise. 2.81. What is the ratio of the Debt(current US$) in Rwanda in 1996 to that in 2001?
Make the answer very short. 0.94. What is the ratio of the Debt(current US$) of Belarus in 1996 to that in 2002?
Offer a terse response. 4.05. What is the ratio of the Debt(current US$) in Georgia in 1996 to that in 2002?
Provide a succinct answer. 0.34. What is the ratio of the Debt(current US$) in Pakistan in 1996 to that in 2002?
Offer a very short reply. 2.63. What is the ratio of the Debt(current US$) in Rwanda in 1996 to that in 2002?
Make the answer very short. 0.84. What is the ratio of the Debt(current US$) of Belarus in 1997 to that in 1998?
Your answer should be compact. 2.39. What is the ratio of the Debt(current US$) of Georgia in 1997 to that in 1998?
Offer a terse response. 0.67. What is the ratio of the Debt(current US$) of Pakistan in 1997 to that in 1998?
Give a very brief answer. 1.07. What is the ratio of the Debt(current US$) in Rwanda in 1997 to that in 1998?
Make the answer very short. 1.12. What is the ratio of the Debt(current US$) in Belarus in 1997 to that in 1999?
Your response must be concise. 4.02. What is the ratio of the Debt(current US$) of Georgia in 1997 to that in 1999?
Your answer should be very brief. 0.55. What is the ratio of the Debt(current US$) in Pakistan in 1997 to that in 1999?
Offer a very short reply. 1.33. What is the ratio of the Debt(current US$) of Rwanda in 1997 to that in 1999?
Offer a very short reply. 1.04. What is the ratio of the Debt(current US$) in Belarus in 1997 to that in 2000?
Keep it short and to the point. 3.05. What is the ratio of the Debt(current US$) of Georgia in 1997 to that in 2000?
Give a very brief answer. 0.52. What is the ratio of the Debt(current US$) of Pakistan in 1997 to that in 2000?
Offer a very short reply. 2.08. What is the ratio of the Debt(current US$) in Rwanda in 1997 to that in 2000?
Your answer should be very brief. 1.05. What is the ratio of the Debt(current US$) in Belarus in 1997 to that in 2001?
Keep it short and to the point. 1.67. What is the ratio of the Debt(current US$) of Georgia in 1997 to that in 2001?
Make the answer very short. 0.52. What is the ratio of the Debt(current US$) of Pakistan in 1997 to that in 2001?
Your response must be concise. 2.18. What is the ratio of the Debt(current US$) of Rwanda in 1997 to that in 2001?
Your response must be concise. 0.8. What is the ratio of the Debt(current US$) of Belarus in 1997 to that in 2002?
Offer a terse response. 4.57. What is the ratio of the Debt(current US$) of Georgia in 1997 to that in 2002?
Provide a short and direct response. 0.58. What is the ratio of the Debt(current US$) in Pakistan in 1997 to that in 2002?
Ensure brevity in your answer.  2.05. What is the ratio of the Debt(current US$) of Rwanda in 1997 to that in 2002?
Offer a terse response. 0.72. What is the ratio of the Debt(current US$) in Belarus in 1998 to that in 1999?
Your answer should be very brief. 1.69. What is the ratio of the Debt(current US$) of Georgia in 1998 to that in 1999?
Make the answer very short. 0.82. What is the ratio of the Debt(current US$) of Pakistan in 1998 to that in 1999?
Keep it short and to the point. 1.24. What is the ratio of the Debt(current US$) in Rwanda in 1998 to that in 1999?
Your answer should be compact. 0.93. What is the ratio of the Debt(current US$) in Belarus in 1998 to that in 2000?
Keep it short and to the point. 1.28. What is the ratio of the Debt(current US$) of Georgia in 1998 to that in 2000?
Ensure brevity in your answer.  0.78. What is the ratio of the Debt(current US$) of Pakistan in 1998 to that in 2000?
Provide a succinct answer. 1.94. What is the ratio of the Debt(current US$) in Rwanda in 1998 to that in 2000?
Ensure brevity in your answer.  0.94. What is the ratio of the Debt(current US$) in Belarus in 1998 to that in 2001?
Your response must be concise. 0.7. What is the ratio of the Debt(current US$) of Georgia in 1998 to that in 2001?
Ensure brevity in your answer.  0.78. What is the ratio of the Debt(current US$) of Pakistan in 1998 to that in 2001?
Provide a short and direct response. 2.04. What is the ratio of the Debt(current US$) of Rwanda in 1998 to that in 2001?
Offer a very short reply. 0.71. What is the ratio of the Debt(current US$) in Belarus in 1998 to that in 2002?
Your answer should be compact. 1.92. What is the ratio of the Debt(current US$) in Georgia in 1998 to that in 2002?
Give a very brief answer. 0.86. What is the ratio of the Debt(current US$) in Pakistan in 1998 to that in 2002?
Offer a terse response. 1.91. What is the ratio of the Debt(current US$) of Rwanda in 1998 to that in 2002?
Offer a very short reply. 0.64. What is the ratio of the Debt(current US$) of Belarus in 1999 to that in 2000?
Your answer should be compact. 0.76. What is the ratio of the Debt(current US$) in Georgia in 1999 to that in 2000?
Offer a terse response. 0.96. What is the ratio of the Debt(current US$) in Pakistan in 1999 to that in 2000?
Offer a terse response. 1.57. What is the ratio of the Debt(current US$) of Rwanda in 1999 to that in 2000?
Offer a very short reply. 1. What is the ratio of the Debt(current US$) of Belarus in 1999 to that in 2001?
Offer a very short reply. 0.41. What is the ratio of the Debt(current US$) in Georgia in 1999 to that in 2001?
Offer a terse response. 0.96. What is the ratio of the Debt(current US$) in Pakistan in 1999 to that in 2001?
Provide a short and direct response. 1.64. What is the ratio of the Debt(current US$) in Rwanda in 1999 to that in 2001?
Your answer should be very brief. 0.77. What is the ratio of the Debt(current US$) of Belarus in 1999 to that in 2002?
Your answer should be very brief. 1.14. What is the ratio of the Debt(current US$) in Georgia in 1999 to that in 2002?
Give a very brief answer. 1.06. What is the ratio of the Debt(current US$) in Pakistan in 1999 to that in 2002?
Make the answer very short. 1.54. What is the ratio of the Debt(current US$) in Rwanda in 1999 to that in 2002?
Provide a succinct answer. 0.69. What is the ratio of the Debt(current US$) in Belarus in 2000 to that in 2001?
Offer a very short reply. 0.55. What is the ratio of the Debt(current US$) in Georgia in 2000 to that in 2001?
Make the answer very short. 1. What is the ratio of the Debt(current US$) in Pakistan in 2000 to that in 2001?
Give a very brief answer. 1.05. What is the ratio of the Debt(current US$) in Rwanda in 2000 to that in 2001?
Provide a succinct answer. 0.76. What is the ratio of the Debt(current US$) of Belarus in 2000 to that in 2002?
Offer a very short reply. 1.5. What is the ratio of the Debt(current US$) of Georgia in 2000 to that in 2002?
Make the answer very short. 1.1. What is the ratio of the Debt(current US$) of Pakistan in 2000 to that in 2002?
Your response must be concise. 0.98. What is the ratio of the Debt(current US$) of Rwanda in 2000 to that in 2002?
Your answer should be very brief. 0.68. What is the ratio of the Debt(current US$) of Belarus in 2001 to that in 2002?
Your response must be concise. 2.74. What is the ratio of the Debt(current US$) in Georgia in 2001 to that in 2002?
Keep it short and to the point. 1.11. What is the ratio of the Debt(current US$) in Pakistan in 2001 to that in 2002?
Keep it short and to the point. 0.94. What is the ratio of the Debt(current US$) of Rwanda in 2001 to that in 2002?
Keep it short and to the point. 0.9. What is the difference between the highest and the second highest Debt(current US$) of Belarus?
Provide a short and direct response. 5.06e+07. What is the difference between the highest and the second highest Debt(current US$) in Georgia?
Your answer should be compact. 1.02e+06. What is the difference between the highest and the second highest Debt(current US$) of Pakistan?
Provide a succinct answer. 5.32e+08. What is the difference between the highest and the second highest Debt(current US$) in Rwanda?
Keep it short and to the point. 5.49e+07. What is the difference between the highest and the lowest Debt(current US$) of Belarus?
Offer a terse response. 1.91e+08. What is the difference between the highest and the lowest Debt(current US$) of Georgia?
Offer a very short reply. 3.05e+08. What is the difference between the highest and the lowest Debt(current US$) of Pakistan?
Keep it short and to the point. 6.08e+09. What is the difference between the highest and the lowest Debt(current US$) in Rwanda?
Ensure brevity in your answer.  1.82e+08. 